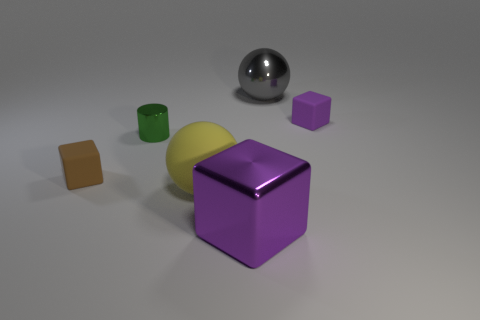Add 4 brown metallic balls. How many objects exist? 10 Subtract all cylinders. How many objects are left? 5 Subtract 0 cyan cylinders. How many objects are left? 6 Subtract all small blue things. Subtract all brown blocks. How many objects are left? 5 Add 1 green metallic cylinders. How many green metallic cylinders are left? 2 Add 5 small shiny things. How many small shiny things exist? 6 